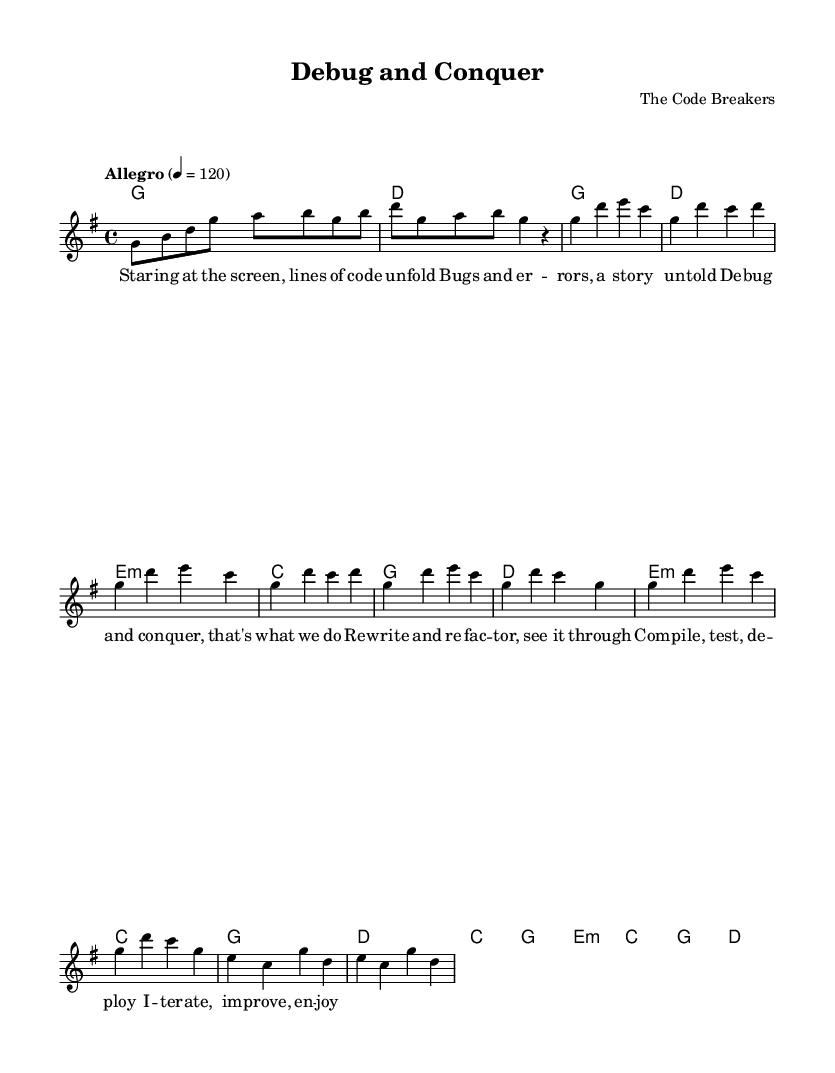What is the key signature of this music? The key signature is G major, which has one sharp (F#). This can be determined by looking at the key signature at the beginning of the score, where the sharp is indicated.
Answer: G major What is the time signature of the piece? The time signature is 4/4, as indicated on the staff at the beginning of the score. This means there are four beats in a measure and a quarter note receives one beat.
Answer: 4/4 What is the tempo marking of the piece? The tempo marking is "Allegro" at a speed of 120 beats per minute. This is shown in the tempo section at the beginning of the piece.
Answer: Allegro, 120 How many measures are in the chorus section? The chorus section consists of four measures which can be counted by looking specifically at the section labeled as the chorus within the score and counting the measures.
Answer: 4 What harmonic progression is used in the chorus? The harmonic progression in the chorus is G, D, E minor, C, which can be identified by looking at the chord symbols written above the melody in that section.
Answer: G, D, E minor, C Which section includes the lyrics "Debug and conquer, that's what we do"? These lyrics are found in the chorus section of the song, as indicated by the corresponding lyrics written under the melody line.
Answer: Chorus What is the mood expressed in the music through its dynamic and tempo? The music expresses an upbeat and motivating mood, supported by the allegro tempo and major key, which typically evoke feelings of excitement and positivity. This can be inferred from the tempo marking and the overall major tonality of the piece.
Answer: Upbeat and motivating 